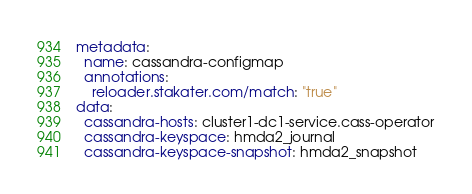Convert code to text. <code><loc_0><loc_0><loc_500><loc_500><_YAML_>metadata:
  name: cassandra-configmap
  annotations:
    reloader.stakater.com/match: "true"
data:
  cassandra-hosts: cluster1-dc1-service.cass-operator
  cassandra-keyspace: hmda2_journal
  cassandra-keyspace-snapshot: hmda2_snapshot
</code> 